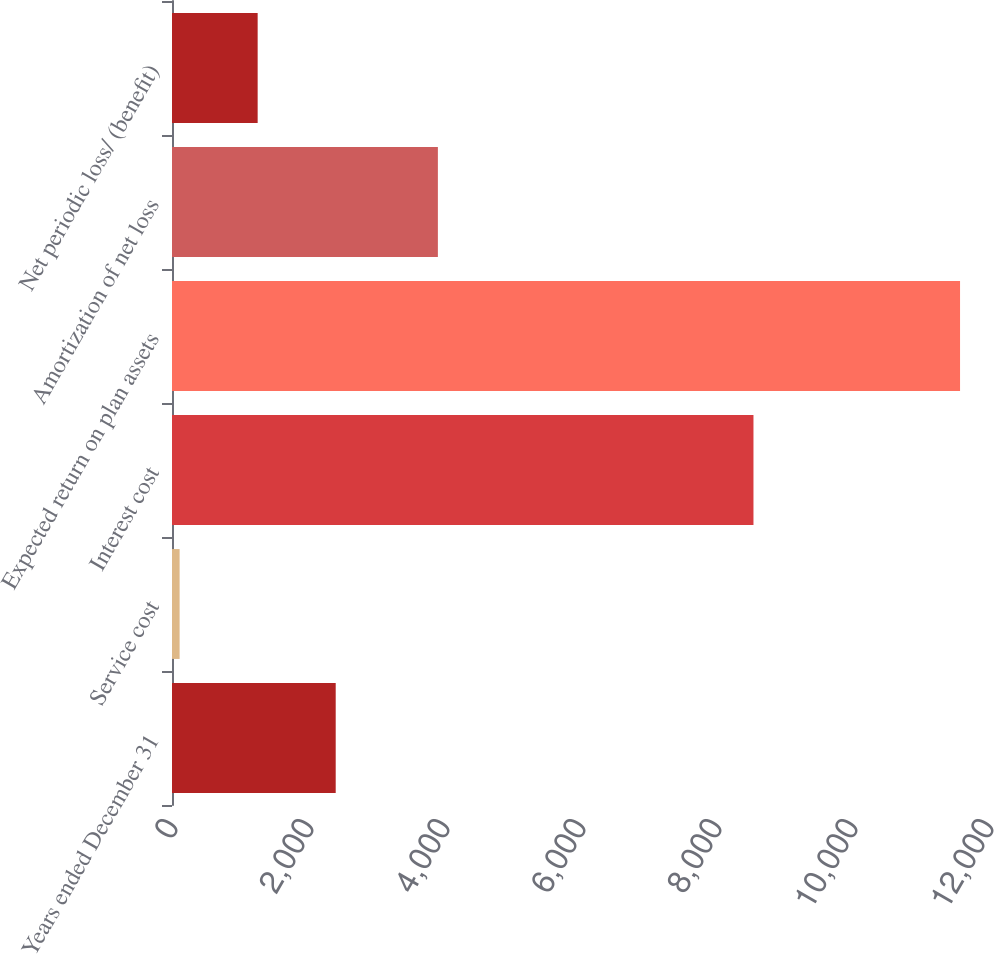Convert chart to OTSL. <chart><loc_0><loc_0><loc_500><loc_500><bar_chart><fcel>Years ended December 31<fcel>Service cost<fcel>Interest cost<fcel>Expected return on plan assets<fcel>Amortization of net loss<fcel>Net periodic loss/ (benefit)<nl><fcel>2407.4<fcel>112<fcel>8551<fcel>11589<fcel>3910<fcel>1259.7<nl></chart> 